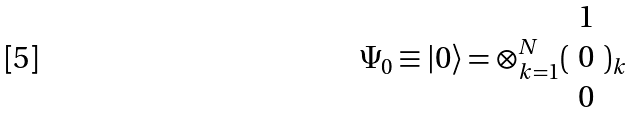<formula> <loc_0><loc_0><loc_500><loc_500>\Psi _ { 0 } \equiv | 0 \rangle = \otimes _ { k = 1 } ^ { N } ( \begin{array} { c } 1 \\ 0 \\ 0 \end{array} ) _ { k }</formula> 